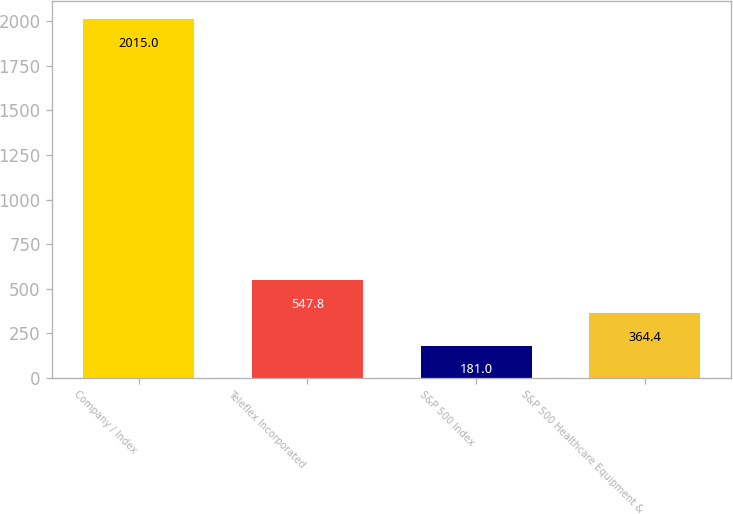<chart> <loc_0><loc_0><loc_500><loc_500><bar_chart><fcel>Company / Index<fcel>Teleflex Incorporated<fcel>S&P 500 Index<fcel>S&P 500 Healthcare Equipment &<nl><fcel>2015<fcel>547.8<fcel>181<fcel>364.4<nl></chart> 